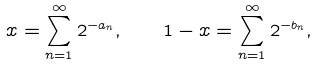Convert formula to latex. <formula><loc_0><loc_0><loc_500><loc_500>x = \sum _ { n = 1 } ^ { \infty } 2 ^ { - a _ { n } } , \quad 1 - x = \sum _ { n = 1 } ^ { \infty } 2 ^ { - b _ { n } } ,</formula> 